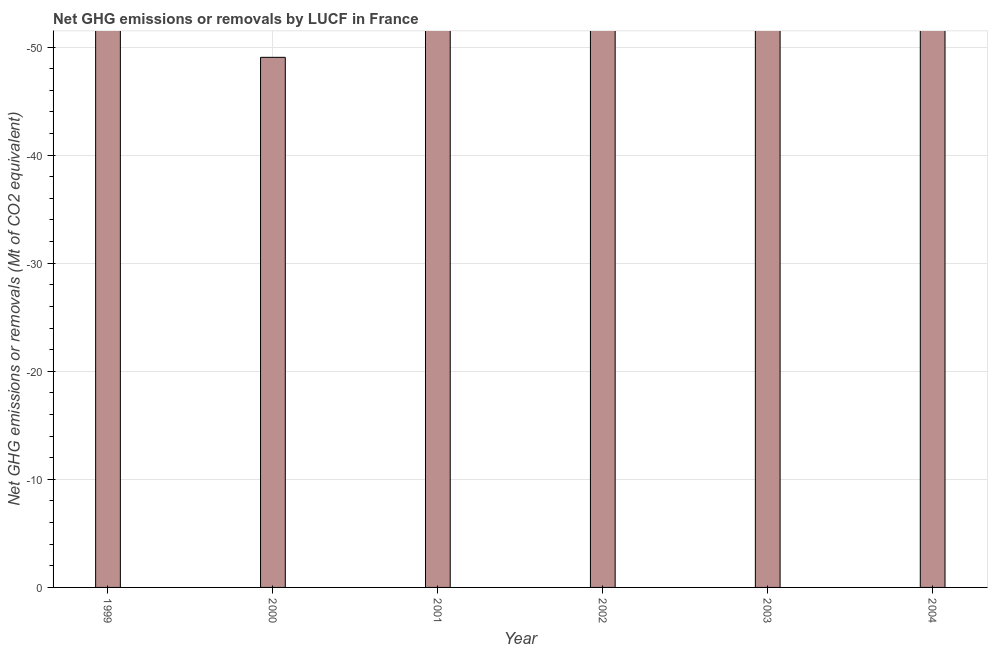Does the graph contain any zero values?
Your answer should be compact. Yes. What is the title of the graph?
Make the answer very short. Net GHG emissions or removals by LUCF in France. What is the label or title of the Y-axis?
Your answer should be very brief. Net GHG emissions or removals (Mt of CO2 equivalent). What is the ghg net emissions or removals in 2001?
Your answer should be very brief. 0. What is the sum of the ghg net emissions or removals?
Offer a very short reply. 0. What is the average ghg net emissions or removals per year?
Provide a short and direct response. 0. In how many years, is the ghg net emissions or removals greater than -24 Mt?
Offer a very short reply. 0. How many bars are there?
Provide a short and direct response. 0. Are all the bars in the graph horizontal?
Your response must be concise. No. What is the difference between two consecutive major ticks on the Y-axis?
Provide a succinct answer. 10. Are the values on the major ticks of Y-axis written in scientific E-notation?
Offer a terse response. No. What is the Net GHG emissions or removals (Mt of CO2 equivalent) of 1999?
Ensure brevity in your answer.  0. What is the Net GHG emissions or removals (Mt of CO2 equivalent) in 2000?
Provide a short and direct response. 0. What is the Net GHG emissions or removals (Mt of CO2 equivalent) of 2001?
Make the answer very short. 0. What is the Net GHG emissions or removals (Mt of CO2 equivalent) in 2002?
Provide a succinct answer. 0. What is the Net GHG emissions or removals (Mt of CO2 equivalent) in 2003?
Your response must be concise. 0. 